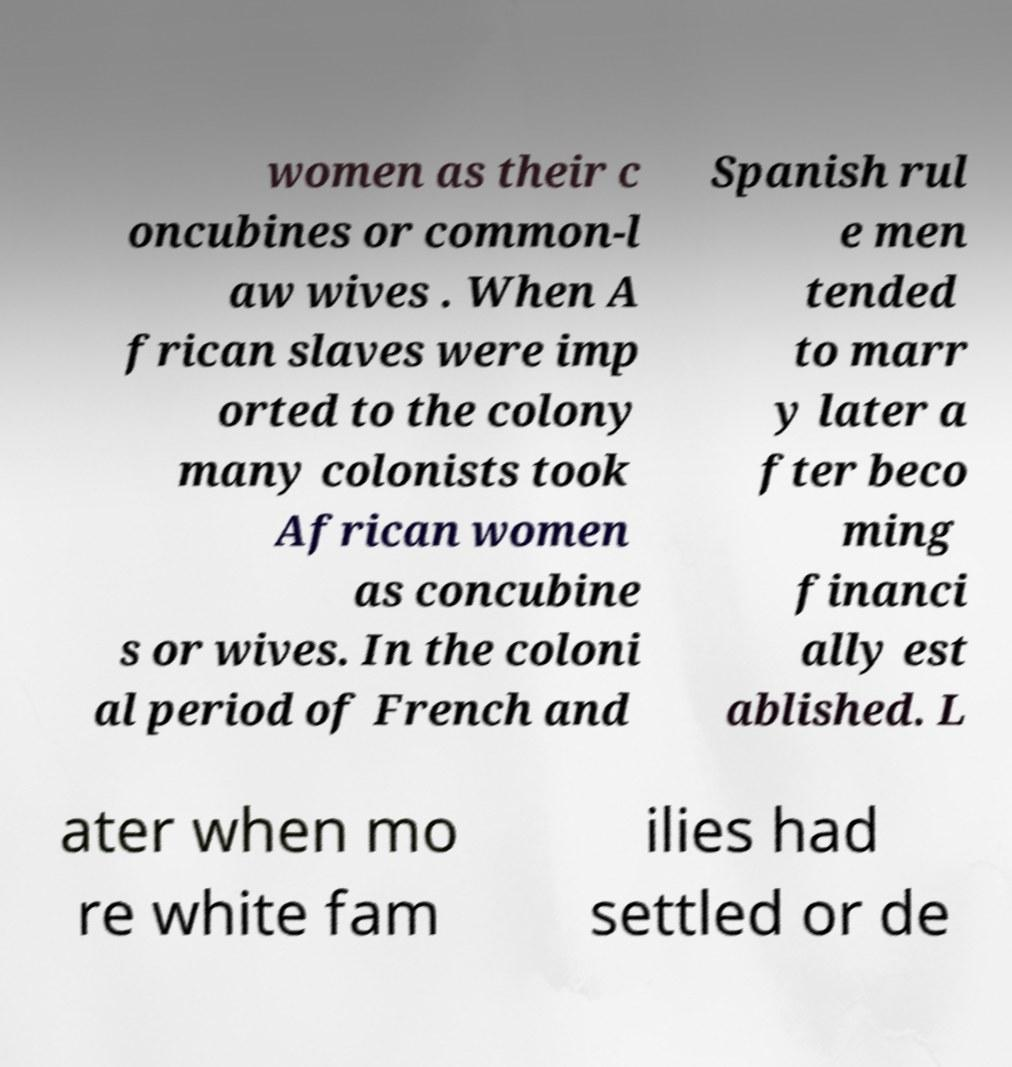Could you assist in decoding the text presented in this image and type it out clearly? women as their c oncubines or common-l aw wives . When A frican slaves were imp orted to the colony many colonists took African women as concubine s or wives. In the coloni al period of French and Spanish rul e men tended to marr y later a fter beco ming financi ally est ablished. L ater when mo re white fam ilies had settled or de 